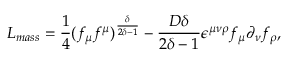Convert formula to latex. <formula><loc_0><loc_0><loc_500><loc_500>L _ { m a s s } = \frac { 1 } { 4 } ( f _ { \mu } f ^ { \mu } ) ^ { \frac { \delta } { 2 \delta - 1 } } - \frac { D \delta } { 2 \delta - 1 } \epsilon ^ { \mu \nu \rho } f _ { \mu } \partial _ { \nu } f _ { \rho } ,</formula> 